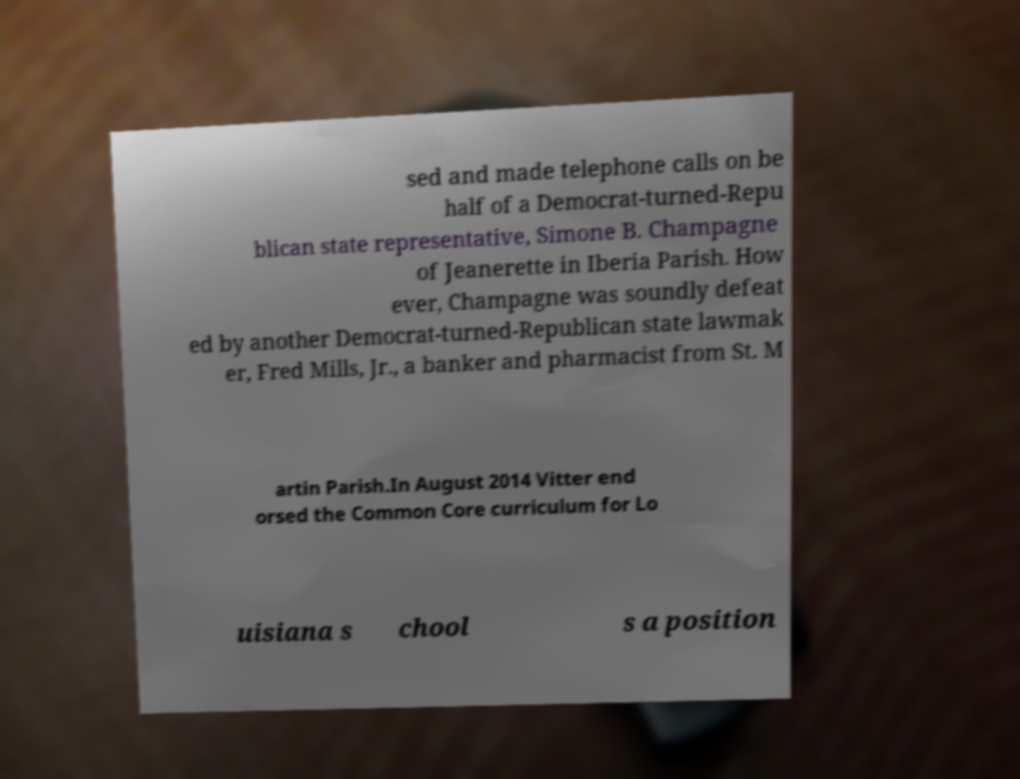Could you assist in decoding the text presented in this image and type it out clearly? sed and made telephone calls on be half of a Democrat-turned-Repu blican state representative, Simone B. Champagne of Jeanerette in Iberia Parish. How ever, Champagne was soundly defeat ed by another Democrat-turned-Republican state lawmak er, Fred Mills, Jr., a banker and pharmacist from St. M artin Parish.In August 2014 Vitter end orsed the Common Core curriculum for Lo uisiana s chool s a position 